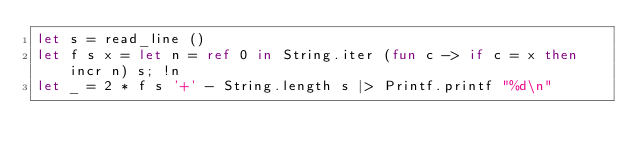<code> <loc_0><loc_0><loc_500><loc_500><_OCaml_>let s = read_line ()
let f s x = let n = ref 0 in String.iter (fun c -> if c = x then incr n) s; !n
let _ = 2 * f s '+' - String.length s |> Printf.printf "%d\n"</code> 